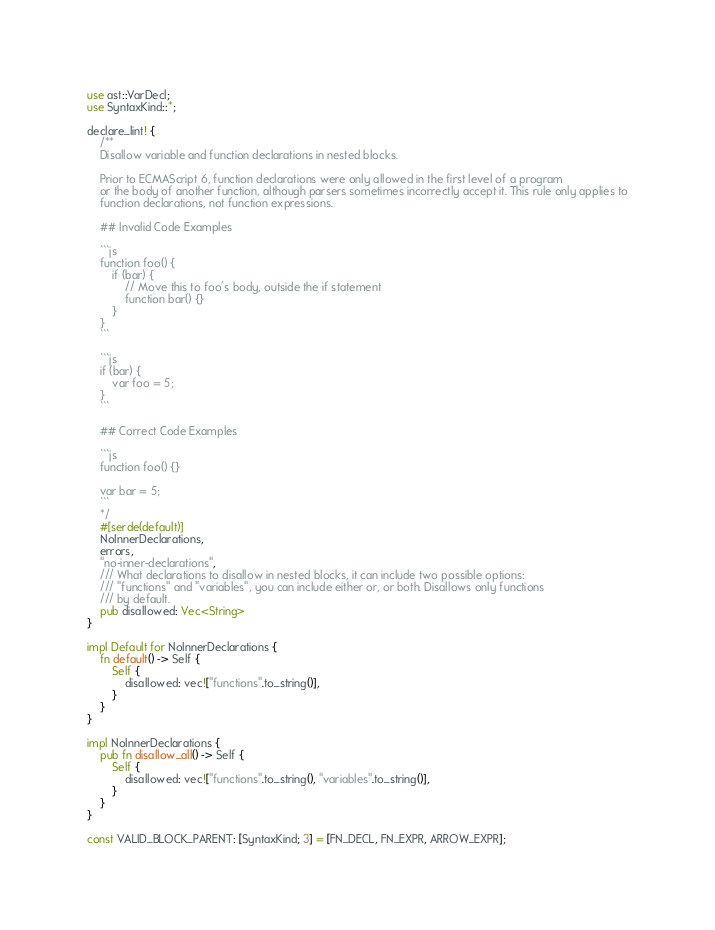<code> <loc_0><loc_0><loc_500><loc_500><_Rust_>use ast::VarDecl;
use SyntaxKind::*;

declare_lint! {
    /**
    Disallow variable and function declarations in nested blocks.

    Prior to ECMAScript 6, function declarations were only allowed in the first level of a program
    or the body of another function, although parsers sometimes incorrectly accept it. This rule only applies to
    function declarations, not function expressions.

    ## Invalid Code Examples

    ```js
    function foo() {
        if (bar) {
            // Move this to foo's body, outside the if statement
            function bar() {}
        }
    }
    ```

    ```js
    if (bar) {
        var foo = 5;
    }
    ```

    ## Correct Code Examples

    ```js
    function foo() {}

    var bar = 5;
    ```
    */
    #[serde(default)]
    NoInnerDeclarations,
    errors,
    "no-inner-declarations",
    /// What declarations to disallow in nested blocks, it can include two possible options:
    /// "functions" and "variables", you can include either or, or both. Disallows only functions
    /// by default.
    pub disallowed: Vec<String>
}

impl Default for NoInnerDeclarations {
    fn default() -> Self {
        Self {
            disallowed: vec!["functions".to_string()],
        }
    }
}

impl NoInnerDeclarations {
    pub fn disallow_all() -> Self {
        Self {
            disallowed: vec!["functions".to_string(), "variables".to_string()],
        }
    }
}

const VALID_BLOCK_PARENT: [SyntaxKind; 3] = [FN_DECL, FN_EXPR, ARROW_EXPR];</code> 